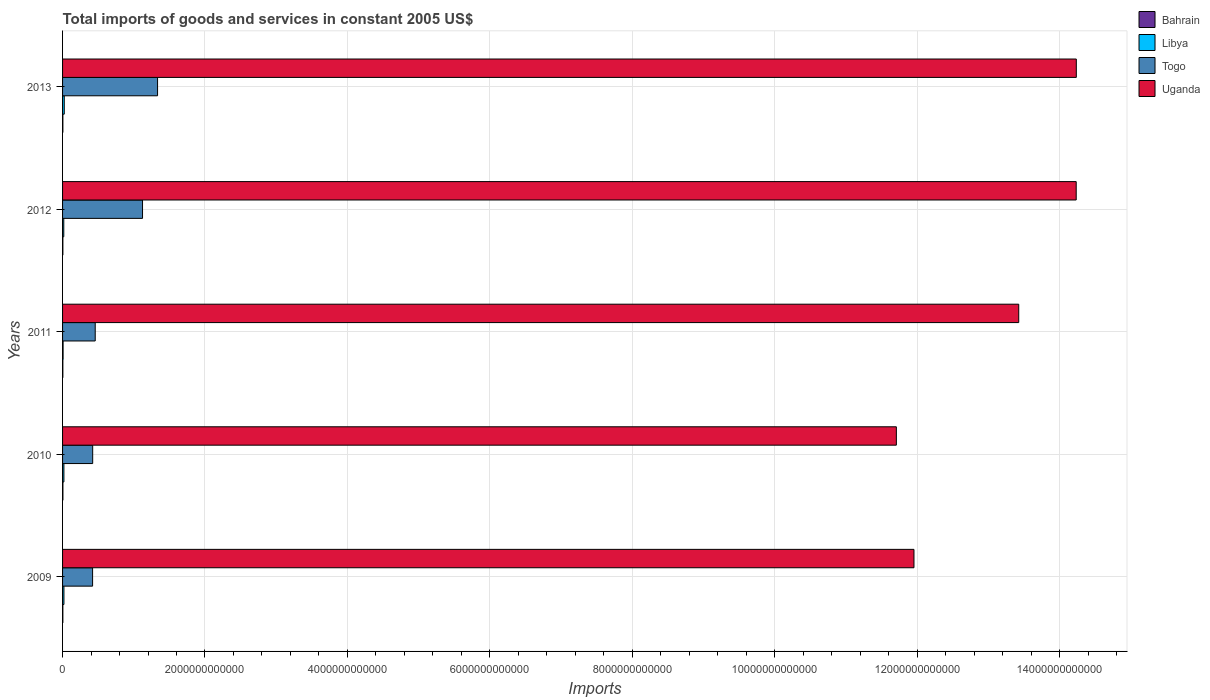How many different coloured bars are there?
Offer a very short reply. 4. How many bars are there on the 4th tick from the top?
Offer a terse response. 4. How many bars are there on the 2nd tick from the bottom?
Provide a short and direct response. 4. In how many cases, is the number of bars for a given year not equal to the number of legend labels?
Make the answer very short. 0. What is the total imports of goods and services in Uganda in 2010?
Make the answer very short. 1.17e+13. Across all years, what is the maximum total imports of goods and services in Libya?
Keep it short and to the point. 2.38e+1. Across all years, what is the minimum total imports of goods and services in Togo?
Ensure brevity in your answer.  4.22e+11. In which year was the total imports of goods and services in Togo maximum?
Provide a short and direct response. 2013. What is the total total imports of goods and services in Libya in the graph?
Your response must be concise. 8.63e+1. What is the difference between the total imports of goods and services in Togo in 2009 and that in 2010?
Offer a terse response. -1.44e+09. What is the difference between the total imports of goods and services in Bahrain in 2010 and the total imports of goods and services in Togo in 2011?
Provide a short and direct response. -4.54e+11. What is the average total imports of goods and services in Uganda per year?
Give a very brief answer. 1.31e+13. In the year 2013, what is the difference between the total imports of goods and services in Libya and total imports of goods and services in Bahrain?
Ensure brevity in your answer.  1.94e+1. In how many years, is the total imports of goods and services in Libya greater than 9200000000000 US$?
Give a very brief answer. 0. What is the ratio of the total imports of goods and services in Bahrain in 2009 to that in 2010?
Your response must be concise. 0.85. Is the difference between the total imports of goods and services in Libya in 2009 and 2013 greater than the difference between the total imports of goods and services in Bahrain in 2009 and 2013?
Offer a terse response. No. What is the difference between the highest and the second highest total imports of goods and services in Togo?
Your answer should be very brief. 2.11e+11. What is the difference between the highest and the lowest total imports of goods and services in Bahrain?
Provide a succinct answer. 7.28e+08. Is the sum of the total imports of goods and services in Bahrain in 2010 and 2011 greater than the maximum total imports of goods and services in Togo across all years?
Provide a short and direct response. No. What does the 1st bar from the top in 2012 represents?
Your answer should be very brief. Uganda. What does the 1st bar from the bottom in 2013 represents?
Offer a very short reply. Bahrain. Are all the bars in the graph horizontal?
Your answer should be compact. Yes. How many years are there in the graph?
Your response must be concise. 5. What is the difference between two consecutive major ticks on the X-axis?
Make the answer very short. 2.00e+12. Are the values on the major ticks of X-axis written in scientific E-notation?
Ensure brevity in your answer.  No. Does the graph contain any zero values?
Your answer should be very brief. No. Does the graph contain grids?
Keep it short and to the point. Yes. How are the legend labels stacked?
Make the answer very short. Vertical. What is the title of the graph?
Offer a very short reply. Total imports of goods and services in constant 2005 US$. What is the label or title of the X-axis?
Offer a terse response. Imports. What is the Imports in Bahrain in 2009?
Your response must be concise. 4.20e+09. What is the Imports in Libya in 2009?
Ensure brevity in your answer.  1.93e+1. What is the Imports in Togo in 2009?
Your answer should be very brief. 4.22e+11. What is the Imports in Uganda in 2009?
Keep it short and to the point. 1.20e+13. What is the Imports of Bahrain in 2010?
Keep it short and to the point. 4.92e+09. What is the Imports of Libya in 2010?
Provide a short and direct response. 1.88e+1. What is the Imports of Togo in 2010?
Your answer should be very brief. 4.23e+11. What is the Imports of Uganda in 2010?
Keep it short and to the point. 1.17e+13. What is the Imports of Bahrain in 2011?
Offer a very short reply. 4.20e+09. What is the Imports in Libya in 2011?
Make the answer very short. 7.36e+09. What is the Imports in Togo in 2011?
Ensure brevity in your answer.  4.59e+11. What is the Imports of Uganda in 2011?
Your answer should be compact. 1.34e+13. What is the Imports of Bahrain in 2012?
Offer a very short reply. 4.30e+09. What is the Imports in Libya in 2012?
Offer a terse response. 1.71e+1. What is the Imports of Togo in 2012?
Provide a short and direct response. 1.12e+12. What is the Imports in Uganda in 2012?
Make the answer very short. 1.42e+13. What is the Imports in Bahrain in 2013?
Provide a succinct answer. 4.33e+09. What is the Imports in Libya in 2013?
Offer a terse response. 2.38e+1. What is the Imports in Togo in 2013?
Provide a succinct answer. 1.33e+12. What is the Imports in Uganda in 2013?
Make the answer very short. 1.42e+13. Across all years, what is the maximum Imports of Bahrain?
Make the answer very short. 4.92e+09. Across all years, what is the maximum Imports in Libya?
Provide a succinct answer. 2.38e+1. Across all years, what is the maximum Imports in Togo?
Your answer should be compact. 1.33e+12. Across all years, what is the maximum Imports of Uganda?
Offer a terse response. 1.42e+13. Across all years, what is the minimum Imports of Bahrain?
Your answer should be very brief. 4.20e+09. Across all years, what is the minimum Imports of Libya?
Provide a succinct answer. 7.36e+09. Across all years, what is the minimum Imports in Togo?
Ensure brevity in your answer.  4.22e+11. Across all years, what is the minimum Imports in Uganda?
Offer a very short reply. 1.17e+13. What is the total Imports in Bahrain in the graph?
Provide a short and direct response. 2.19e+1. What is the total Imports in Libya in the graph?
Provide a short and direct response. 8.63e+1. What is the total Imports in Togo in the graph?
Keep it short and to the point. 3.76e+12. What is the total Imports of Uganda in the graph?
Provide a short and direct response. 6.56e+13. What is the difference between the Imports of Bahrain in 2009 and that in 2010?
Ensure brevity in your answer.  -7.26e+08. What is the difference between the Imports in Libya in 2009 and that in 2010?
Your answer should be compact. 5.16e+08. What is the difference between the Imports of Togo in 2009 and that in 2010?
Your response must be concise. -1.44e+09. What is the difference between the Imports of Uganda in 2009 and that in 2010?
Offer a very short reply. 2.47e+11. What is the difference between the Imports of Bahrain in 2009 and that in 2011?
Offer a very short reply. 1.00e+06. What is the difference between the Imports of Libya in 2009 and that in 2011?
Provide a succinct answer. 1.19e+1. What is the difference between the Imports of Togo in 2009 and that in 2011?
Your response must be concise. -3.69e+1. What is the difference between the Imports of Uganda in 2009 and that in 2011?
Offer a terse response. -1.47e+12. What is the difference between the Imports of Bahrain in 2009 and that in 2012?
Provide a succinct answer. -9.70e+07. What is the difference between the Imports in Libya in 2009 and that in 2012?
Your answer should be very brief. 2.20e+09. What is the difference between the Imports of Togo in 2009 and that in 2012?
Offer a very short reply. -7.01e+11. What is the difference between the Imports of Uganda in 2009 and that in 2012?
Keep it short and to the point. -2.28e+12. What is the difference between the Imports of Bahrain in 2009 and that in 2013?
Ensure brevity in your answer.  -1.34e+08. What is the difference between the Imports of Libya in 2009 and that in 2013?
Give a very brief answer. -4.51e+09. What is the difference between the Imports of Togo in 2009 and that in 2013?
Your answer should be very brief. -9.12e+11. What is the difference between the Imports in Uganda in 2009 and that in 2013?
Provide a short and direct response. -2.28e+12. What is the difference between the Imports of Bahrain in 2010 and that in 2011?
Make the answer very short. 7.28e+08. What is the difference between the Imports of Libya in 2010 and that in 2011?
Provide a succinct answer. 1.14e+1. What is the difference between the Imports in Togo in 2010 and that in 2011?
Offer a terse response. -3.55e+1. What is the difference between the Imports in Uganda in 2010 and that in 2011?
Ensure brevity in your answer.  -1.72e+12. What is the difference between the Imports in Bahrain in 2010 and that in 2012?
Your response must be concise. 6.30e+08. What is the difference between the Imports in Libya in 2010 and that in 2012?
Provide a short and direct response. 1.69e+09. What is the difference between the Imports in Togo in 2010 and that in 2012?
Your response must be concise. -7.00e+11. What is the difference between the Imports of Uganda in 2010 and that in 2012?
Make the answer very short. -2.53e+12. What is the difference between the Imports of Bahrain in 2010 and that in 2013?
Keep it short and to the point. 5.92e+08. What is the difference between the Imports in Libya in 2010 and that in 2013?
Offer a very short reply. -5.02e+09. What is the difference between the Imports in Togo in 2010 and that in 2013?
Provide a succinct answer. -9.11e+11. What is the difference between the Imports in Uganda in 2010 and that in 2013?
Offer a very short reply. -2.53e+12. What is the difference between the Imports in Bahrain in 2011 and that in 2012?
Make the answer very short. -9.80e+07. What is the difference between the Imports in Libya in 2011 and that in 2012?
Provide a short and direct response. -9.71e+09. What is the difference between the Imports of Togo in 2011 and that in 2012?
Your answer should be very brief. -6.64e+11. What is the difference between the Imports of Uganda in 2011 and that in 2012?
Provide a short and direct response. -8.07e+11. What is the difference between the Imports in Bahrain in 2011 and that in 2013?
Keep it short and to the point. -1.35e+08. What is the difference between the Imports of Libya in 2011 and that in 2013?
Offer a terse response. -1.64e+1. What is the difference between the Imports of Togo in 2011 and that in 2013?
Make the answer very short. -8.76e+11. What is the difference between the Imports in Uganda in 2011 and that in 2013?
Provide a short and direct response. -8.09e+11. What is the difference between the Imports of Bahrain in 2012 and that in 2013?
Give a very brief answer. -3.70e+07. What is the difference between the Imports in Libya in 2012 and that in 2013?
Make the answer very short. -6.71e+09. What is the difference between the Imports of Togo in 2012 and that in 2013?
Your answer should be very brief. -2.11e+11. What is the difference between the Imports in Uganda in 2012 and that in 2013?
Make the answer very short. -1.57e+09. What is the difference between the Imports of Bahrain in 2009 and the Imports of Libya in 2010?
Offer a very short reply. -1.46e+1. What is the difference between the Imports of Bahrain in 2009 and the Imports of Togo in 2010?
Make the answer very short. -4.19e+11. What is the difference between the Imports of Bahrain in 2009 and the Imports of Uganda in 2010?
Ensure brevity in your answer.  -1.17e+13. What is the difference between the Imports in Libya in 2009 and the Imports in Togo in 2010?
Provide a succinct answer. -4.04e+11. What is the difference between the Imports of Libya in 2009 and the Imports of Uganda in 2010?
Offer a terse response. -1.17e+13. What is the difference between the Imports in Togo in 2009 and the Imports in Uganda in 2010?
Your answer should be compact. -1.13e+13. What is the difference between the Imports of Bahrain in 2009 and the Imports of Libya in 2011?
Keep it short and to the point. -3.17e+09. What is the difference between the Imports in Bahrain in 2009 and the Imports in Togo in 2011?
Ensure brevity in your answer.  -4.54e+11. What is the difference between the Imports of Bahrain in 2009 and the Imports of Uganda in 2011?
Provide a succinct answer. -1.34e+13. What is the difference between the Imports in Libya in 2009 and the Imports in Togo in 2011?
Provide a short and direct response. -4.39e+11. What is the difference between the Imports in Libya in 2009 and the Imports in Uganda in 2011?
Your response must be concise. -1.34e+13. What is the difference between the Imports in Togo in 2009 and the Imports in Uganda in 2011?
Give a very brief answer. -1.30e+13. What is the difference between the Imports in Bahrain in 2009 and the Imports in Libya in 2012?
Keep it short and to the point. -1.29e+1. What is the difference between the Imports of Bahrain in 2009 and the Imports of Togo in 2012?
Ensure brevity in your answer.  -1.12e+12. What is the difference between the Imports in Bahrain in 2009 and the Imports in Uganda in 2012?
Your answer should be compact. -1.42e+13. What is the difference between the Imports of Libya in 2009 and the Imports of Togo in 2012?
Keep it short and to the point. -1.10e+12. What is the difference between the Imports in Libya in 2009 and the Imports in Uganda in 2012?
Make the answer very short. -1.42e+13. What is the difference between the Imports of Togo in 2009 and the Imports of Uganda in 2012?
Your answer should be compact. -1.38e+13. What is the difference between the Imports in Bahrain in 2009 and the Imports in Libya in 2013?
Make the answer very short. -1.96e+1. What is the difference between the Imports in Bahrain in 2009 and the Imports in Togo in 2013?
Offer a terse response. -1.33e+12. What is the difference between the Imports of Bahrain in 2009 and the Imports of Uganda in 2013?
Ensure brevity in your answer.  -1.42e+13. What is the difference between the Imports of Libya in 2009 and the Imports of Togo in 2013?
Keep it short and to the point. -1.31e+12. What is the difference between the Imports of Libya in 2009 and the Imports of Uganda in 2013?
Your response must be concise. -1.42e+13. What is the difference between the Imports in Togo in 2009 and the Imports in Uganda in 2013?
Provide a short and direct response. -1.38e+13. What is the difference between the Imports in Bahrain in 2010 and the Imports in Libya in 2011?
Keep it short and to the point. -2.44e+09. What is the difference between the Imports of Bahrain in 2010 and the Imports of Togo in 2011?
Provide a short and direct response. -4.54e+11. What is the difference between the Imports of Bahrain in 2010 and the Imports of Uganda in 2011?
Offer a very short reply. -1.34e+13. What is the difference between the Imports of Libya in 2010 and the Imports of Togo in 2011?
Your answer should be very brief. -4.40e+11. What is the difference between the Imports of Libya in 2010 and the Imports of Uganda in 2011?
Your response must be concise. -1.34e+13. What is the difference between the Imports in Togo in 2010 and the Imports in Uganda in 2011?
Your answer should be compact. -1.30e+13. What is the difference between the Imports of Bahrain in 2010 and the Imports of Libya in 2012?
Your answer should be very brief. -1.21e+1. What is the difference between the Imports in Bahrain in 2010 and the Imports in Togo in 2012?
Your answer should be compact. -1.12e+12. What is the difference between the Imports of Bahrain in 2010 and the Imports of Uganda in 2012?
Ensure brevity in your answer.  -1.42e+13. What is the difference between the Imports of Libya in 2010 and the Imports of Togo in 2012?
Offer a terse response. -1.10e+12. What is the difference between the Imports of Libya in 2010 and the Imports of Uganda in 2012?
Provide a short and direct response. -1.42e+13. What is the difference between the Imports of Togo in 2010 and the Imports of Uganda in 2012?
Your response must be concise. -1.38e+13. What is the difference between the Imports in Bahrain in 2010 and the Imports in Libya in 2013?
Your answer should be compact. -1.89e+1. What is the difference between the Imports of Bahrain in 2010 and the Imports of Togo in 2013?
Offer a terse response. -1.33e+12. What is the difference between the Imports of Bahrain in 2010 and the Imports of Uganda in 2013?
Make the answer very short. -1.42e+13. What is the difference between the Imports in Libya in 2010 and the Imports in Togo in 2013?
Your response must be concise. -1.32e+12. What is the difference between the Imports in Libya in 2010 and the Imports in Uganda in 2013?
Your answer should be compact. -1.42e+13. What is the difference between the Imports of Togo in 2010 and the Imports of Uganda in 2013?
Ensure brevity in your answer.  -1.38e+13. What is the difference between the Imports in Bahrain in 2011 and the Imports in Libya in 2012?
Your response must be concise. -1.29e+1. What is the difference between the Imports of Bahrain in 2011 and the Imports of Togo in 2012?
Provide a short and direct response. -1.12e+12. What is the difference between the Imports of Bahrain in 2011 and the Imports of Uganda in 2012?
Offer a terse response. -1.42e+13. What is the difference between the Imports of Libya in 2011 and the Imports of Togo in 2012?
Your answer should be very brief. -1.12e+12. What is the difference between the Imports of Libya in 2011 and the Imports of Uganda in 2012?
Make the answer very short. -1.42e+13. What is the difference between the Imports of Togo in 2011 and the Imports of Uganda in 2012?
Keep it short and to the point. -1.38e+13. What is the difference between the Imports in Bahrain in 2011 and the Imports in Libya in 2013?
Make the answer very short. -1.96e+1. What is the difference between the Imports in Bahrain in 2011 and the Imports in Togo in 2013?
Ensure brevity in your answer.  -1.33e+12. What is the difference between the Imports in Bahrain in 2011 and the Imports in Uganda in 2013?
Offer a very short reply. -1.42e+13. What is the difference between the Imports in Libya in 2011 and the Imports in Togo in 2013?
Keep it short and to the point. -1.33e+12. What is the difference between the Imports in Libya in 2011 and the Imports in Uganda in 2013?
Offer a terse response. -1.42e+13. What is the difference between the Imports in Togo in 2011 and the Imports in Uganda in 2013?
Keep it short and to the point. -1.38e+13. What is the difference between the Imports of Bahrain in 2012 and the Imports of Libya in 2013?
Ensure brevity in your answer.  -1.95e+1. What is the difference between the Imports in Bahrain in 2012 and the Imports in Togo in 2013?
Provide a succinct answer. -1.33e+12. What is the difference between the Imports of Bahrain in 2012 and the Imports of Uganda in 2013?
Keep it short and to the point. -1.42e+13. What is the difference between the Imports of Libya in 2012 and the Imports of Togo in 2013?
Ensure brevity in your answer.  -1.32e+12. What is the difference between the Imports in Libya in 2012 and the Imports in Uganda in 2013?
Provide a short and direct response. -1.42e+13. What is the difference between the Imports of Togo in 2012 and the Imports of Uganda in 2013?
Your response must be concise. -1.31e+13. What is the average Imports in Bahrain per year?
Offer a very short reply. 4.39e+09. What is the average Imports in Libya per year?
Your answer should be very brief. 1.73e+1. What is the average Imports of Togo per year?
Make the answer very short. 7.52e+11. What is the average Imports in Uganda per year?
Your answer should be very brief. 1.31e+13. In the year 2009, what is the difference between the Imports in Bahrain and Imports in Libya?
Your answer should be very brief. -1.51e+1. In the year 2009, what is the difference between the Imports in Bahrain and Imports in Togo?
Keep it short and to the point. -4.17e+11. In the year 2009, what is the difference between the Imports in Bahrain and Imports in Uganda?
Provide a short and direct response. -1.20e+13. In the year 2009, what is the difference between the Imports of Libya and Imports of Togo?
Your answer should be very brief. -4.02e+11. In the year 2009, what is the difference between the Imports of Libya and Imports of Uganda?
Give a very brief answer. -1.19e+13. In the year 2009, what is the difference between the Imports of Togo and Imports of Uganda?
Your answer should be compact. -1.15e+13. In the year 2010, what is the difference between the Imports of Bahrain and Imports of Libya?
Offer a very short reply. -1.38e+1. In the year 2010, what is the difference between the Imports of Bahrain and Imports of Togo?
Provide a succinct answer. -4.18e+11. In the year 2010, what is the difference between the Imports of Bahrain and Imports of Uganda?
Provide a succinct answer. -1.17e+13. In the year 2010, what is the difference between the Imports of Libya and Imports of Togo?
Give a very brief answer. -4.04e+11. In the year 2010, what is the difference between the Imports of Libya and Imports of Uganda?
Your answer should be very brief. -1.17e+13. In the year 2010, what is the difference between the Imports in Togo and Imports in Uganda?
Your answer should be compact. -1.13e+13. In the year 2011, what is the difference between the Imports of Bahrain and Imports of Libya?
Your answer should be compact. -3.17e+09. In the year 2011, what is the difference between the Imports in Bahrain and Imports in Togo?
Your answer should be compact. -4.54e+11. In the year 2011, what is the difference between the Imports of Bahrain and Imports of Uganda?
Ensure brevity in your answer.  -1.34e+13. In the year 2011, what is the difference between the Imports of Libya and Imports of Togo?
Your answer should be very brief. -4.51e+11. In the year 2011, what is the difference between the Imports of Libya and Imports of Uganda?
Make the answer very short. -1.34e+13. In the year 2011, what is the difference between the Imports in Togo and Imports in Uganda?
Your response must be concise. -1.30e+13. In the year 2012, what is the difference between the Imports in Bahrain and Imports in Libya?
Offer a very short reply. -1.28e+1. In the year 2012, what is the difference between the Imports of Bahrain and Imports of Togo?
Your answer should be compact. -1.12e+12. In the year 2012, what is the difference between the Imports in Bahrain and Imports in Uganda?
Your response must be concise. -1.42e+13. In the year 2012, what is the difference between the Imports of Libya and Imports of Togo?
Ensure brevity in your answer.  -1.11e+12. In the year 2012, what is the difference between the Imports of Libya and Imports of Uganda?
Your answer should be compact. -1.42e+13. In the year 2012, what is the difference between the Imports of Togo and Imports of Uganda?
Offer a terse response. -1.31e+13. In the year 2013, what is the difference between the Imports of Bahrain and Imports of Libya?
Provide a short and direct response. -1.94e+1. In the year 2013, what is the difference between the Imports in Bahrain and Imports in Togo?
Your response must be concise. -1.33e+12. In the year 2013, what is the difference between the Imports in Bahrain and Imports in Uganda?
Make the answer very short. -1.42e+13. In the year 2013, what is the difference between the Imports of Libya and Imports of Togo?
Make the answer very short. -1.31e+12. In the year 2013, what is the difference between the Imports of Libya and Imports of Uganda?
Your response must be concise. -1.42e+13. In the year 2013, what is the difference between the Imports of Togo and Imports of Uganda?
Your answer should be very brief. -1.29e+13. What is the ratio of the Imports of Bahrain in 2009 to that in 2010?
Keep it short and to the point. 0.85. What is the ratio of the Imports in Libya in 2009 to that in 2010?
Your response must be concise. 1.03. What is the ratio of the Imports of Togo in 2009 to that in 2010?
Give a very brief answer. 1. What is the ratio of the Imports in Uganda in 2009 to that in 2010?
Make the answer very short. 1.02. What is the ratio of the Imports in Libya in 2009 to that in 2011?
Your response must be concise. 2.62. What is the ratio of the Imports in Togo in 2009 to that in 2011?
Offer a terse response. 0.92. What is the ratio of the Imports of Uganda in 2009 to that in 2011?
Your response must be concise. 0.89. What is the ratio of the Imports in Bahrain in 2009 to that in 2012?
Your response must be concise. 0.98. What is the ratio of the Imports in Libya in 2009 to that in 2012?
Make the answer very short. 1.13. What is the ratio of the Imports of Togo in 2009 to that in 2012?
Keep it short and to the point. 0.38. What is the ratio of the Imports in Uganda in 2009 to that in 2012?
Give a very brief answer. 0.84. What is the ratio of the Imports in Bahrain in 2009 to that in 2013?
Ensure brevity in your answer.  0.97. What is the ratio of the Imports in Libya in 2009 to that in 2013?
Give a very brief answer. 0.81. What is the ratio of the Imports in Togo in 2009 to that in 2013?
Ensure brevity in your answer.  0.32. What is the ratio of the Imports in Uganda in 2009 to that in 2013?
Provide a short and direct response. 0.84. What is the ratio of the Imports in Bahrain in 2010 to that in 2011?
Keep it short and to the point. 1.17. What is the ratio of the Imports of Libya in 2010 to that in 2011?
Make the answer very short. 2.55. What is the ratio of the Imports in Togo in 2010 to that in 2011?
Offer a very short reply. 0.92. What is the ratio of the Imports in Uganda in 2010 to that in 2011?
Make the answer very short. 0.87. What is the ratio of the Imports in Bahrain in 2010 to that in 2012?
Your answer should be compact. 1.15. What is the ratio of the Imports in Libya in 2010 to that in 2012?
Offer a very short reply. 1.1. What is the ratio of the Imports in Togo in 2010 to that in 2012?
Make the answer very short. 0.38. What is the ratio of the Imports in Uganda in 2010 to that in 2012?
Ensure brevity in your answer.  0.82. What is the ratio of the Imports in Bahrain in 2010 to that in 2013?
Ensure brevity in your answer.  1.14. What is the ratio of the Imports in Libya in 2010 to that in 2013?
Give a very brief answer. 0.79. What is the ratio of the Imports in Togo in 2010 to that in 2013?
Offer a very short reply. 0.32. What is the ratio of the Imports of Uganda in 2010 to that in 2013?
Your answer should be very brief. 0.82. What is the ratio of the Imports in Bahrain in 2011 to that in 2012?
Ensure brevity in your answer.  0.98. What is the ratio of the Imports in Libya in 2011 to that in 2012?
Provide a short and direct response. 0.43. What is the ratio of the Imports of Togo in 2011 to that in 2012?
Provide a succinct answer. 0.41. What is the ratio of the Imports of Uganda in 2011 to that in 2012?
Your answer should be compact. 0.94. What is the ratio of the Imports of Bahrain in 2011 to that in 2013?
Make the answer very short. 0.97. What is the ratio of the Imports in Libya in 2011 to that in 2013?
Offer a terse response. 0.31. What is the ratio of the Imports of Togo in 2011 to that in 2013?
Your answer should be compact. 0.34. What is the ratio of the Imports of Uganda in 2011 to that in 2013?
Offer a terse response. 0.94. What is the ratio of the Imports in Libya in 2012 to that in 2013?
Your answer should be compact. 0.72. What is the ratio of the Imports in Togo in 2012 to that in 2013?
Ensure brevity in your answer.  0.84. What is the difference between the highest and the second highest Imports in Bahrain?
Offer a terse response. 5.92e+08. What is the difference between the highest and the second highest Imports in Libya?
Keep it short and to the point. 4.51e+09. What is the difference between the highest and the second highest Imports in Togo?
Provide a short and direct response. 2.11e+11. What is the difference between the highest and the second highest Imports in Uganda?
Your answer should be compact. 1.57e+09. What is the difference between the highest and the lowest Imports of Bahrain?
Keep it short and to the point. 7.28e+08. What is the difference between the highest and the lowest Imports of Libya?
Make the answer very short. 1.64e+1. What is the difference between the highest and the lowest Imports of Togo?
Your answer should be very brief. 9.12e+11. What is the difference between the highest and the lowest Imports in Uganda?
Ensure brevity in your answer.  2.53e+12. 